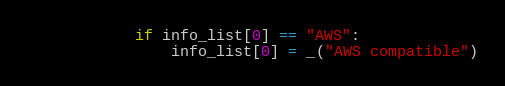Convert code to text. <code><loc_0><loc_0><loc_500><loc_500><_Python_>            if info_list[0] == "AWS":
                info_list[0] = _("AWS compatible")</code> 